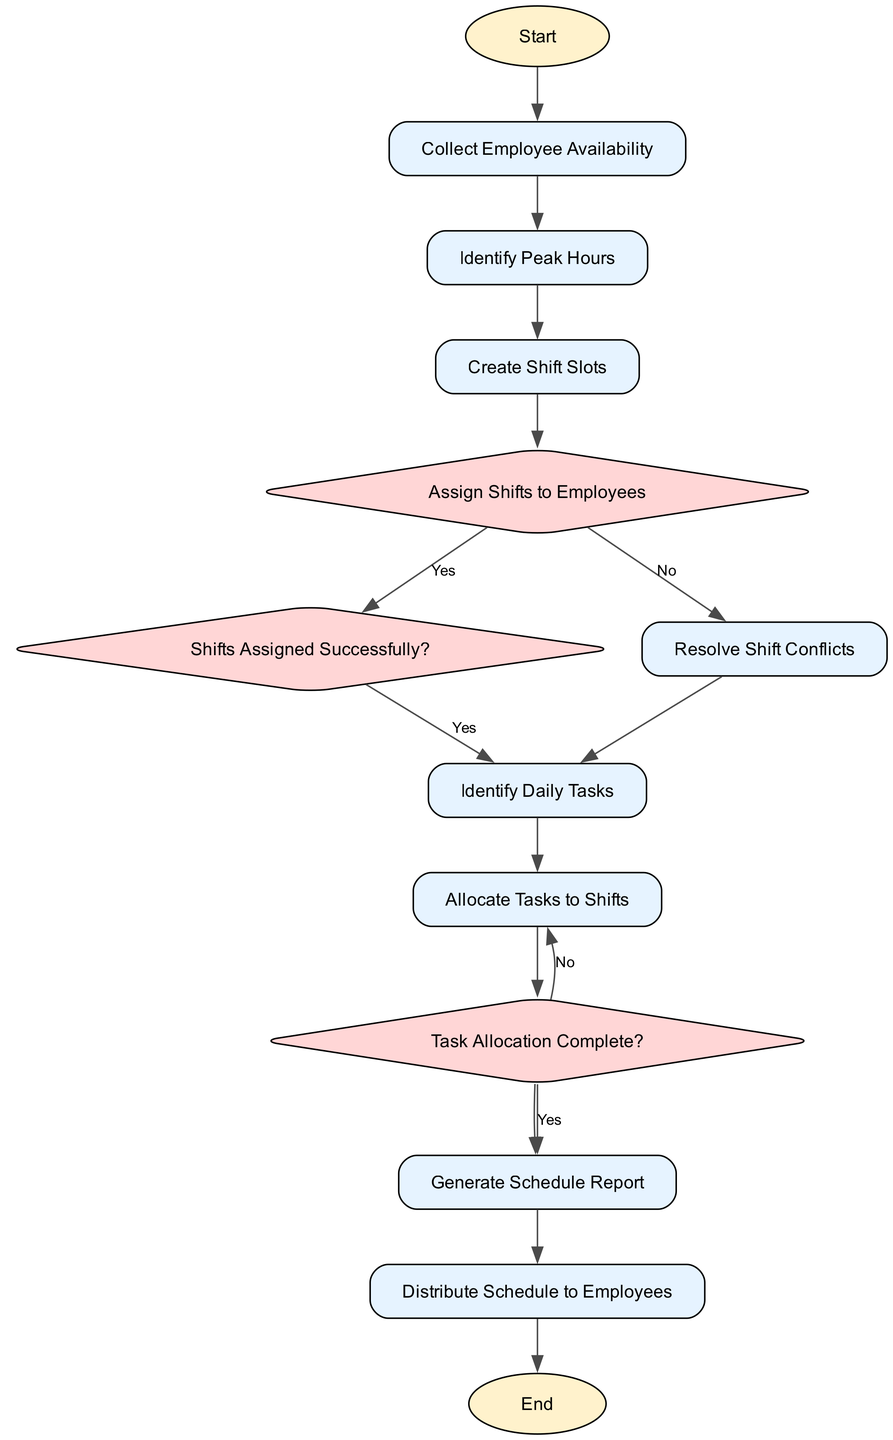What is the first step in the flowchart? The flowchart starts with the "Start" terminal node, indicating the beginning of the employee shift scheduling and task allocation process.
Answer: Start How many decision nodes are in the diagram? The flowchart contains three decision nodes: "Assign Shifts to Employees," "Shifts Assigned Successfully?", and "Task Allocation Complete?".
Answer: 3 What follows after "Identify Peak Hours"? After "Identify Peak Hours," the next step in the flowchart is "Create Shift Slots". This indicates that the process continues by creating the necessary shift time slots.
Answer: Create Shift Slots What happens if shifts are assigned successfully? If shifts are assigned successfully, the flow proceeds to "Identify Daily Tasks," indicating that the next process step involves listing out daily tasks.
Answer: Identify Daily Tasks What is the final process step before reaching the end? The final process step before reaching the end of the flowchart is "Distribute Schedule to Employees," which concludes the flow by sharing the finalized schedule with all employees.
Answer: Distribute Schedule to Employees What action is taken if task allocation is not complete? If task allocation is not complete, the flow directs to "Allocate Tasks to Shifts," indicating that there is a need to reassign specific tasks to employees during their shifts.
Answer: Allocate Tasks to Shifts How many total processes are in the diagram? The flowchart contains a total of eight process nodes: "Collect Employee Availability," "Identify Peak Hours," "Create Shift Slots," "Resolve Shift Conflicts," "Identify Daily Tasks," "Allocate Tasks to Shifts," "Generate Schedule Report," and "Distribute Schedule to Employees."
Answer: 8 What is the purpose of the "Resolve Shift Conflicts" process? The purpose of the "Resolve Shift Conflicts" process is to address and resolve any conflicts that might arise in shift assignments, ensuring a smooth scheduling experience for employees.
Answer: Address conflicts What indicates that the process is complete? The process is complete when reaching the "End" terminal node, which signifies the conclusion of the employee shift scheduling and task allocation process.
Answer: End 